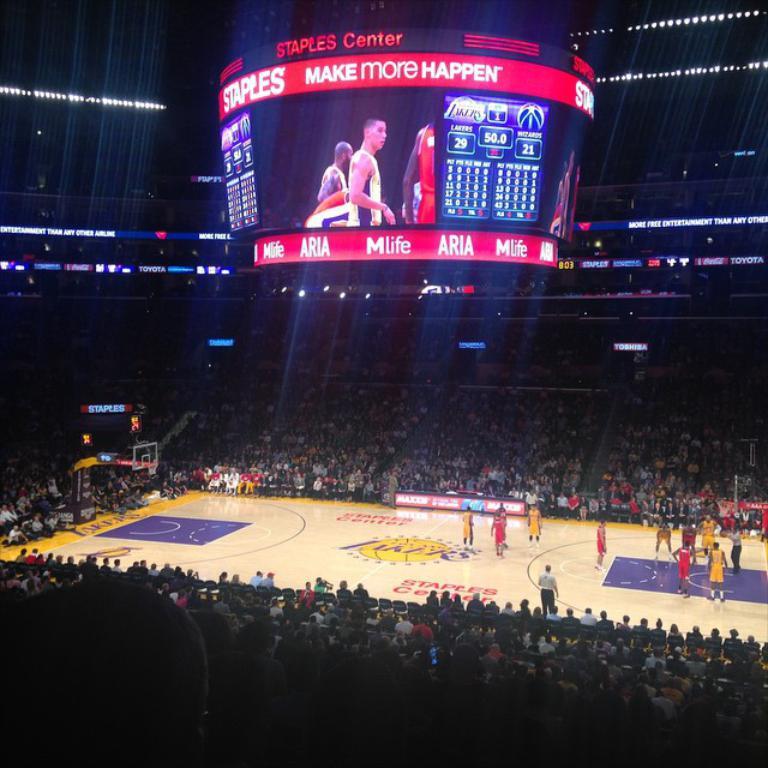What venue are they playing at?
Keep it short and to the point. Staples center. What is the team logo in the middle of the photo?
Provide a succinct answer. Lakers. 